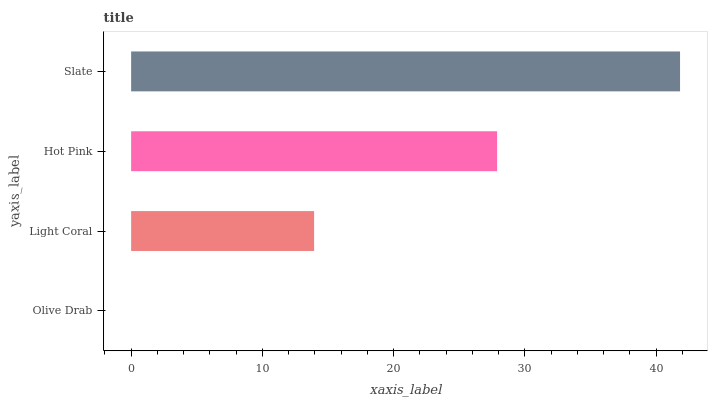Is Olive Drab the minimum?
Answer yes or no. Yes. Is Slate the maximum?
Answer yes or no. Yes. Is Light Coral the minimum?
Answer yes or no. No. Is Light Coral the maximum?
Answer yes or no. No. Is Light Coral greater than Olive Drab?
Answer yes or no. Yes. Is Olive Drab less than Light Coral?
Answer yes or no. Yes. Is Olive Drab greater than Light Coral?
Answer yes or no. No. Is Light Coral less than Olive Drab?
Answer yes or no. No. Is Hot Pink the high median?
Answer yes or no. Yes. Is Light Coral the low median?
Answer yes or no. Yes. Is Light Coral the high median?
Answer yes or no. No. Is Olive Drab the low median?
Answer yes or no. No. 